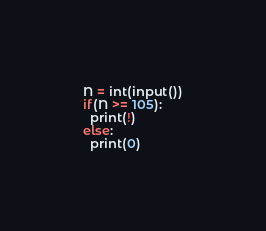<code> <loc_0><loc_0><loc_500><loc_500><_Python_>N = int(input())
if(N >= 105):
  print(!)
else:
  print(0)</code> 